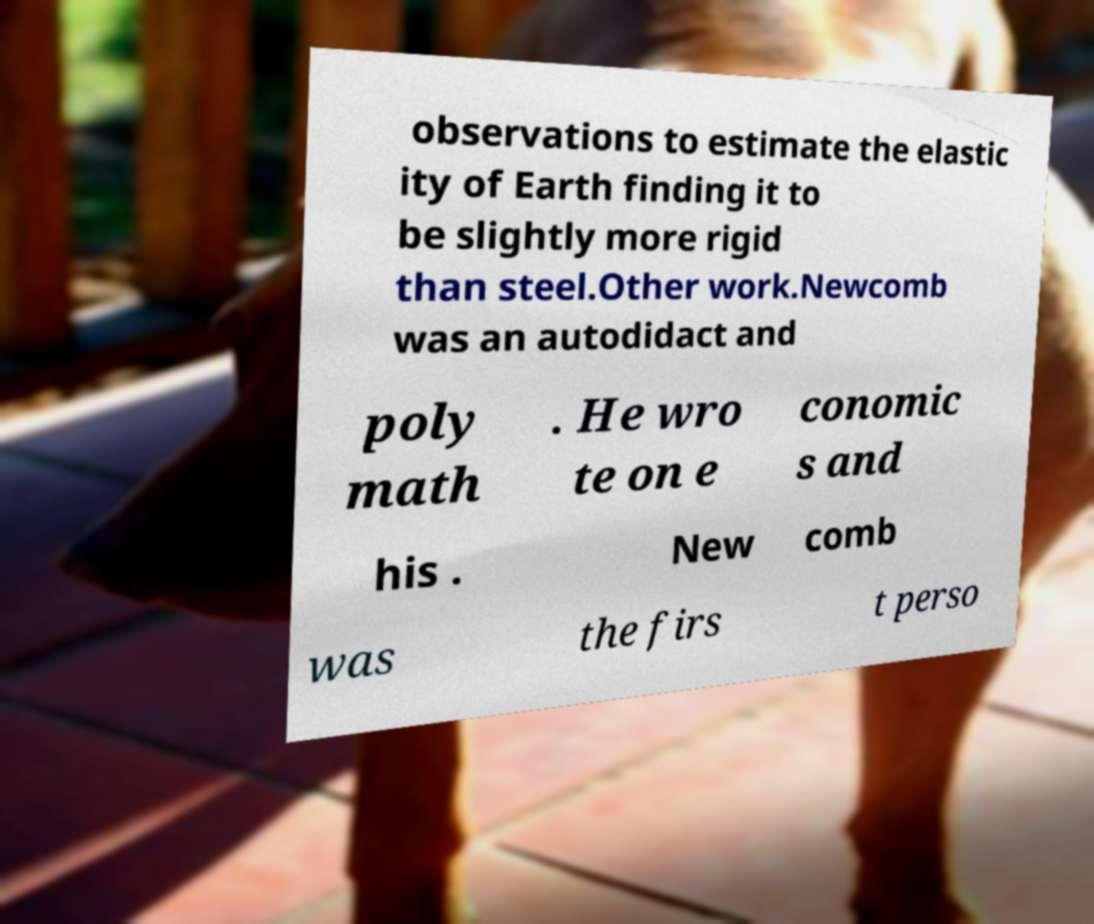Can you read and provide the text displayed in the image?This photo seems to have some interesting text. Can you extract and type it out for me? observations to estimate the elastic ity of Earth finding it to be slightly more rigid than steel.Other work.Newcomb was an autodidact and poly math . He wro te on e conomic s and his . New comb was the firs t perso 